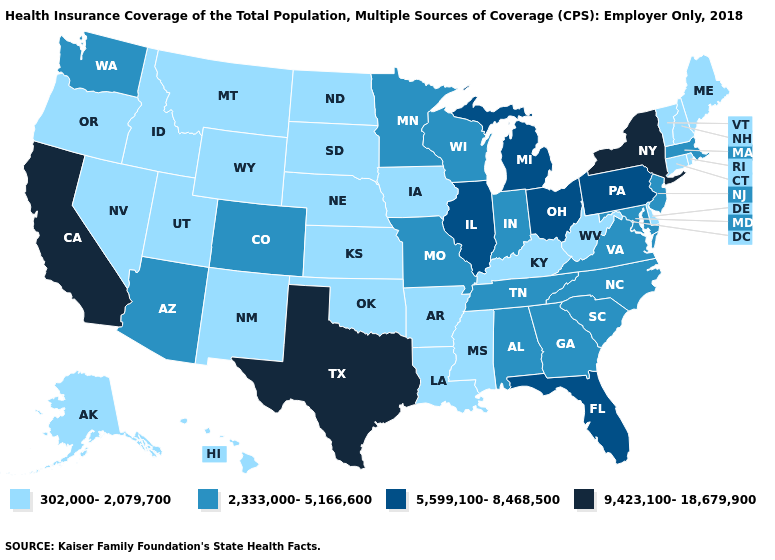What is the highest value in states that border Oregon?
Give a very brief answer. 9,423,100-18,679,900. Name the states that have a value in the range 5,599,100-8,468,500?
Keep it brief. Florida, Illinois, Michigan, Ohio, Pennsylvania. What is the value of New Hampshire?
Write a very short answer. 302,000-2,079,700. Name the states that have a value in the range 9,423,100-18,679,900?
Short answer required. California, New York, Texas. What is the value of Maine?
Quick response, please. 302,000-2,079,700. Does Minnesota have the highest value in the USA?
Answer briefly. No. How many symbols are there in the legend?
Short answer required. 4. What is the lowest value in the MidWest?
Concise answer only. 302,000-2,079,700. Does California have the highest value in the USA?
Be succinct. Yes. Among the states that border Massachusetts , which have the lowest value?
Short answer required. Connecticut, New Hampshire, Rhode Island, Vermont. What is the value of Virginia?
Give a very brief answer. 2,333,000-5,166,600. Does New York have the highest value in the Northeast?
Short answer required. Yes. Does New York have the highest value in the Northeast?
Give a very brief answer. Yes. What is the value of Maryland?
Give a very brief answer. 2,333,000-5,166,600. What is the value of Idaho?
Concise answer only. 302,000-2,079,700. 